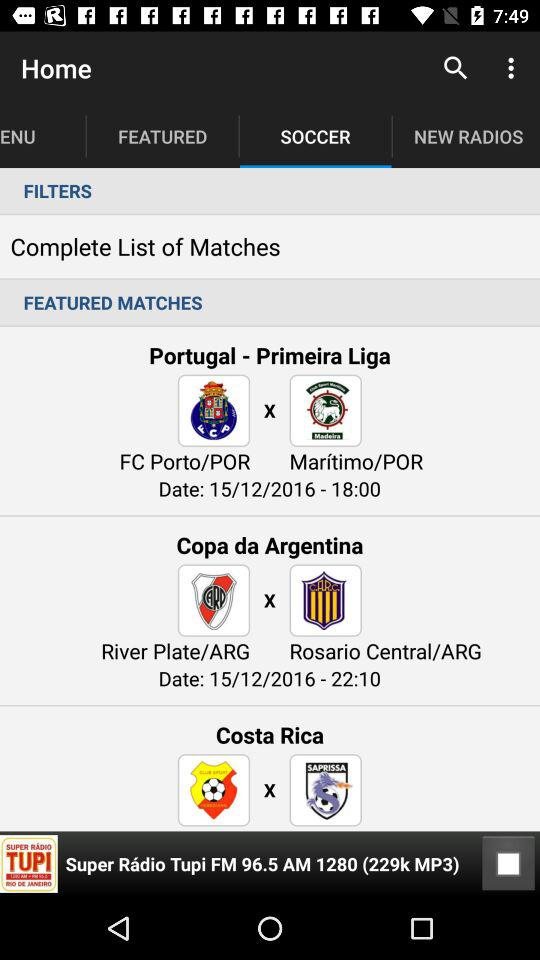What is the date of the matches? The date of the matches is December 15, 2016. 